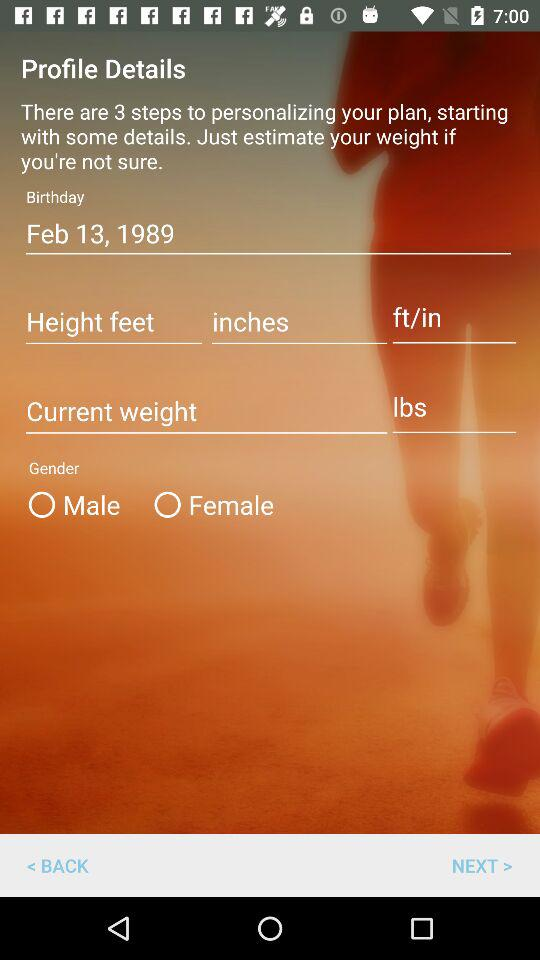What's the birth date? The birth date is February 13, 1989. 